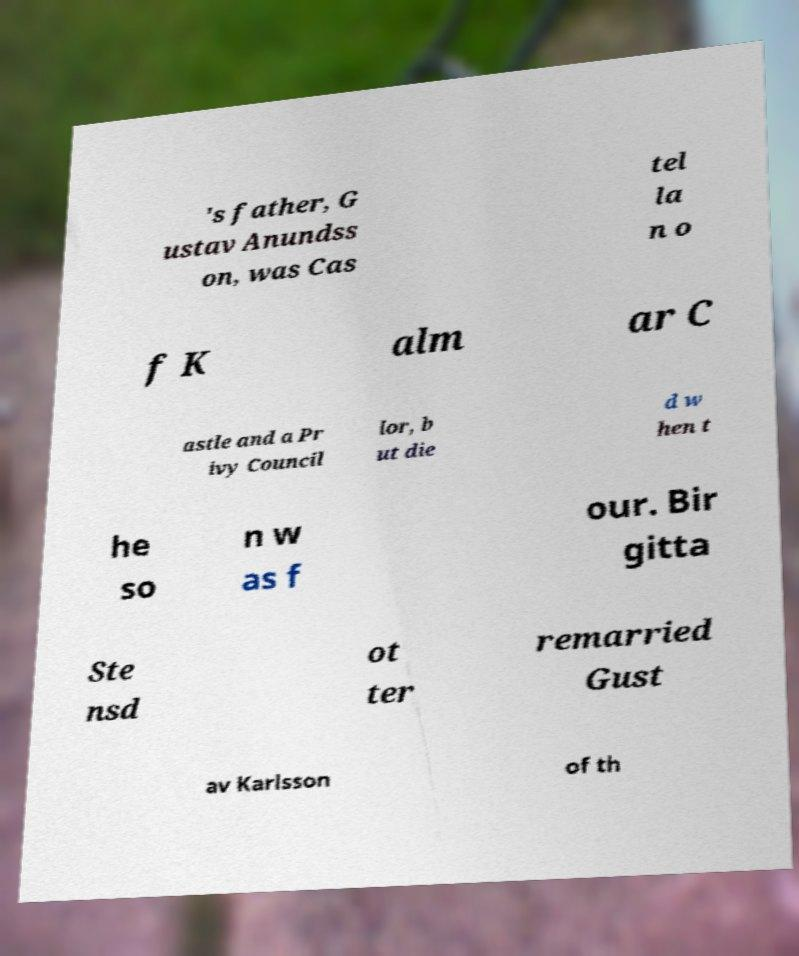I need the written content from this picture converted into text. Can you do that? 's father, G ustav Anundss on, was Cas tel la n o f K alm ar C astle and a Pr ivy Council lor, b ut die d w hen t he so n w as f our. Bir gitta Ste nsd ot ter remarried Gust av Karlsson of th 